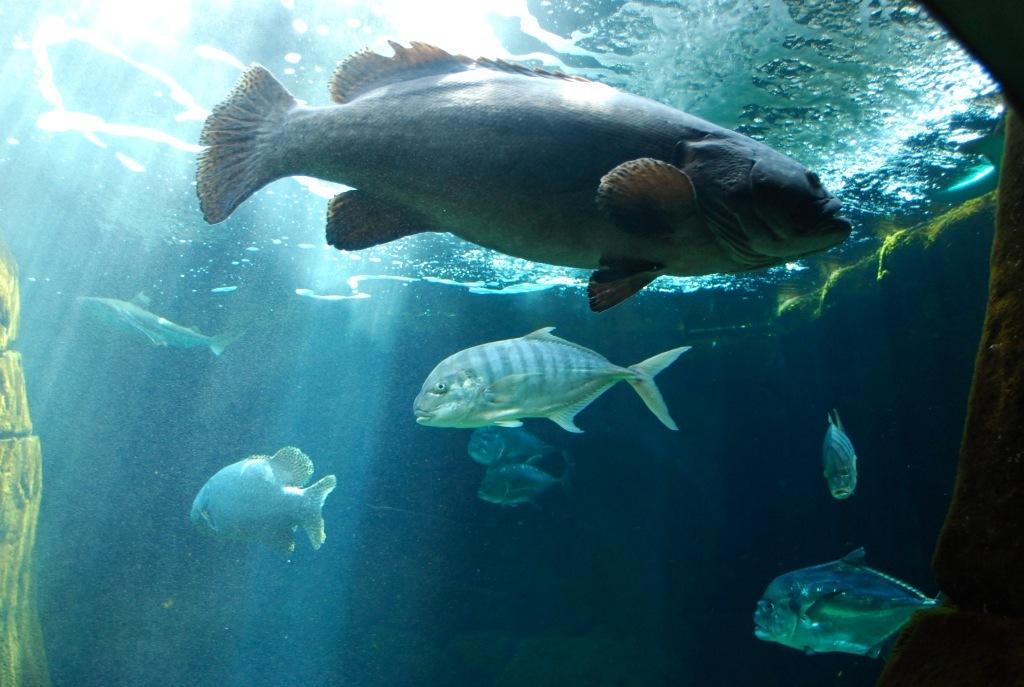Could you give a brief overview of what you see in this image? In this image, we can see fishes in the water. 